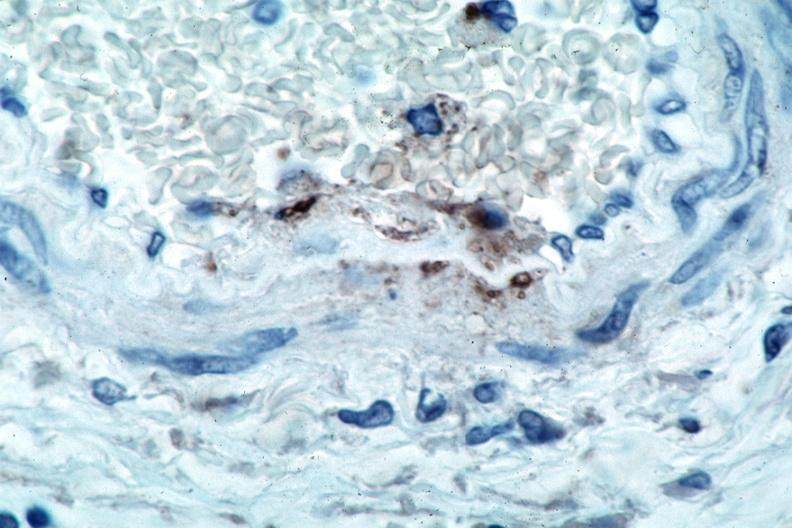s this section spotted fever, immunoperoxidase staining vessels for rickettsia rickettsii?
Answer the question using a single word or phrase. No 